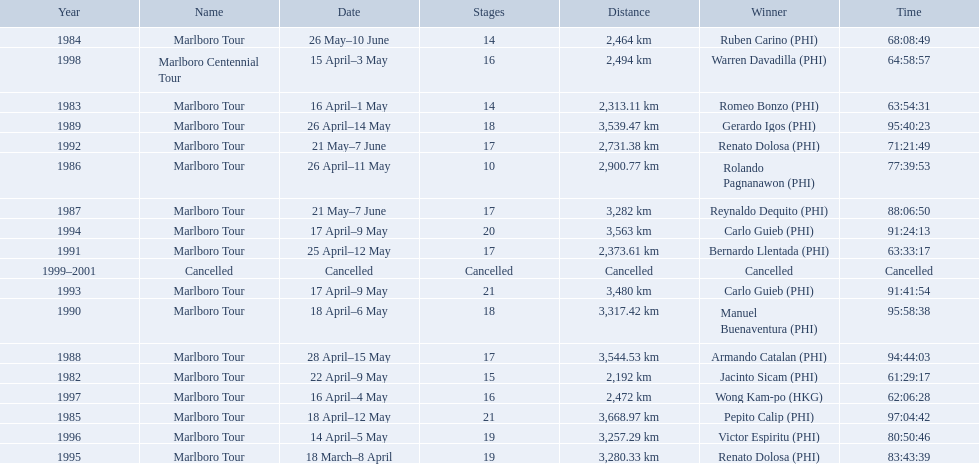Who were all of the winners? Jacinto Sicam (PHI), Romeo Bonzo (PHI), Ruben Carino (PHI), Pepito Calip (PHI), Rolando Pagnanawon (PHI), Reynaldo Dequito (PHI), Armando Catalan (PHI), Gerardo Igos (PHI), Manuel Buenaventura (PHI), Bernardo Llentada (PHI), Renato Dolosa (PHI), Carlo Guieb (PHI), Carlo Guieb (PHI), Renato Dolosa (PHI), Victor Espiritu (PHI), Wong Kam-po (HKG), Warren Davadilla (PHI), Cancelled. When did they compete? 1982, 1983, 1984, 1985, 1986, 1987, 1988, 1989, 1990, 1991, 1992, 1993, 1994, 1995, 1996, 1997, 1998, 1999–2001. What were their finishing times? 61:29:17, 63:54:31, 68:08:49, 97:04:42, 77:39:53, 88:06:50, 94:44:03, 95:40:23, 95:58:38, 63:33:17, 71:21:49, 91:41:54, 91:24:13, 83:43:39, 80:50:46, 62:06:28, 64:58:57, Cancelled. And who won during 1998? Warren Davadilla (PHI). What was his time? 64:58:57. What are the distances travelled on the tour? 2,192 km, 2,313.11 km, 2,464 km, 3,668.97 km, 2,900.77 km, 3,282 km, 3,544.53 km, 3,539.47 km, 3,317.42 km, 2,373.61 km, 2,731.38 km, 3,480 km, 3,563 km, 3,280.33 km, 3,257.29 km, 2,472 km, 2,494 km. Which of these are the largest? 3,668.97 km. Help me parse the entirety of this table. {'header': ['Year', 'Name', 'Date', 'Stages', 'Distance', 'Winner', 'Time'], 'rows': [['1984', 'Marlboro Tour', '26 May–10 June', '14', '2,464\xa0km', 'Ruben Carino\xa0(PHI)', '68:08:49'], ['1998', 'Marlboro Centennial Tour', '15 April–3 May', '16', '2,494\xa0km', 'Warren Davadilla\xa0(PHI)', '64:58:57'], ['1983', 'Marlboro Tour', '16 April–1 May', '14', '2,313.11\xa0km', 'Romeo Bonzo\xa0(PHI)', '63:54:31'], ['1989', 'Marlboro Tour', '26 April–14 May', '18', '3,539.47\xa0km', 'Gerardo Igos\xa0(PHI)', '95:40:23'], ['1992', 'Marlboro Tour', '21 May–7 June', '17', '2,731.38\xa0km', 'Renato Dolosa\xa0(PHI)', '71:21:49'], ['1986', 'Marlboro Tour', '26 April–11 May', '10', '2,900.77\xa0km', 'Rolando Pagnanawon\xa0(PHI)', '77:39:53'], ['1987', 'Marlboro Tour', '21 May–7 June', '17', '3,282\xa0km', 'Reynaldo Dequito\xa0(PHI)', '88:06:50'], ['1994', 'Marlboro Tour', '17 April–9 May', '20', '3,563\xa0km', 'Carlo Guieb\xa0(PHI)', '91:24:13'], ['1991', 'Marlboro Tour', '25 April–12 May', '17', '2,373.61\xa0km', 'Bernardo Llentada\xa0(PHI)', '63:33:17'], ['1999–2001', 'Cancelled', 'Cancelled', 'Cancelled', 'Cancelled', 'Cancelled', 'Cancelled'], ['1993', 'Marlboro Tour', '17 April–9 May', '21', '3,480\xa0km', 'Carlo Guieb\xa0(PHI)', '91:41:54'], ['1990', 'Marlboro Tour', '18 April–6 May', '18', '3,317.42\xa0km', 'Manuel Buenaventura\xa0(PHI)', '95:58:38'], ['1988', 'Marlboro Tour', '28 April–15 May', '17', '3,544.53\xa0km', 'Armando Catalan\xa0(PHI)', '94:44:03'], ['1982', 'Marlboro Tour', '22 April–9 May', '15', '2,192\xa0km', 'Jacinto Sicam\xa0(PHI)', '61:29:17'], ['1997', 'Marlboro Tour', '16 April–4 May', '16', '2,472\xa0km', 'Wong Kam-po\xa0(HKG)', '62:06:28'], ['1985', 'Marlboro Tour', '18 April–12 May', '21', '3,668.97\xa0km', 'Pepito Calip\xa0(PHI)', '97:04:42'], ['1996', 'Marlboro Tour', '14 April–5 May', '19', '3,257.29\xa0km', 'Victor Espiritu\xa0(PHI)', '80:50:46'], ['1995', 'Marlboro Tour', '18 March–8 April', '19', '3,280.33\xa0km', 'Renato Dolosa\xa0(PHI)', '83:43:39']]} 